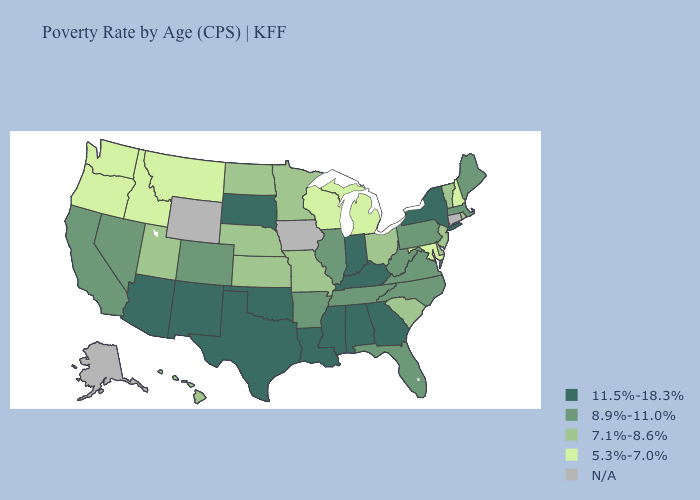Does New Jersey have the lowest value in the USA?
Short answer required. No. What is the highest value in the USA?
Write a very short answer. 11.5%-18.3%. Name the states that have a value in the range 11.5%-18.3%?
Keep it brief. Alabama, Arizona, Georgia, Indiana, Kentucky, Louisiana, Mississippi, New Mexico, New York, Oklahoma, South Dakota, Texas. Does Alabama have the lowest value in the South?
Keep it brief. No. What is the highest value in states that border Florida?
Short answer required. 11.5%-18.3%. Name the states that have a value in the range 8.9%-11.0%?
Give a very brief answer. Arkansas, California, Colorado, Florida, Illinois, Maine, Massachusetts, Nevada, North Carolina, Pennsylvania, Tennessee, Virginia, West Virginia. What is the value of North Dakota?
Answer briefly. 7.1%-8.6%. What is the lowest value in states that border South Carolina?
Answer briefly. 8.9%-11.0%. Among the states that border Massachusetts , which have the highest value?
Concise answer only. New York. Among the states that border Kentucky , does Virginia have the highest value?
Answer briefly. No. What is the lowest value in the USA?
Be succinct. 5.3%-7.0%. What is the value of Nebraska?
Short answer required. 7.1%-8.6%. What is the lowest value in the USA?
Give a very brief answer. 5.3%-7.0%. 